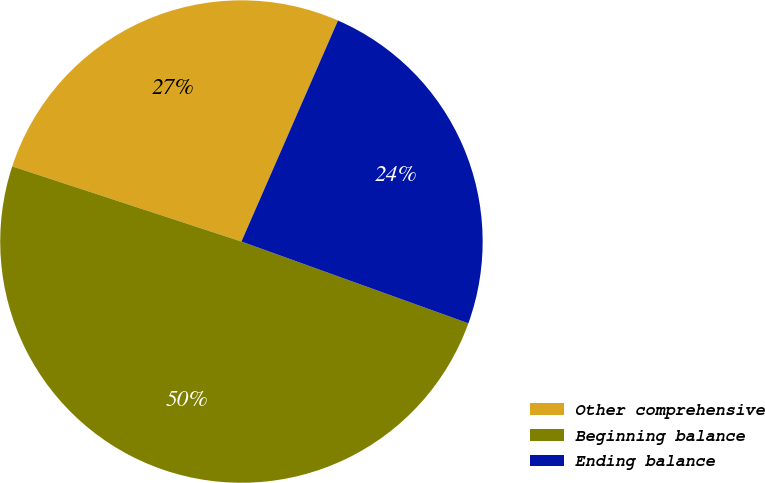<chart> <loc_0><loc_0><loc_500><loc_500><pie_chart><fcel>Other comprehensive<fcel>Beginning balance<fcel>Ending balance<nl><fcel>26.51%<fcel>49.54%<fcel>23.95%<nl></chart> 